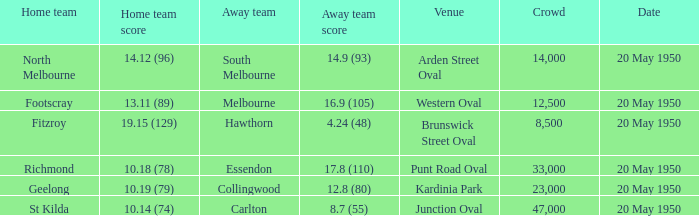I'm looking to parse the entire table for insights. Could you assist me with that? {'header': ['Home team', 'Home team score', 'Away team', 'Away team score', 'Venue', 'Crowd', 'Date'], 'rows': [['North Melbourne', '14.12 (96)', 'South Melbourne', '14.9 (93)', 'Arden Street Oval', '14,000', '20 May 1950'], ['Footscray', '13.11 (89)', 'Melbourne', '16.9 (105)', 'Western Oval', '12,500', '20 May 1950'], ['Fitzroy', '19.15 (129)', 'Hawthorn', '4.24 (48)', 'Brunswick Street Oval', '8,500', '20 May 1950'], ['Richmond', '10.18 (78)', 'Essendon', '17.8 (110)', 'Punt Road Oval', '33,000', '20 May 1950'], ['Geelong', '10.19 (79)', 'Collingwood', '12.8 (80)', 'Kardinia Park', '23,000', '20 May 1950'], ['St Kilda', '10.14 (74)', 'Carlton', '8.7 (55)', 'Junction Oval', '47,000', '20 May 1950']]} When fitzroy played as the home team, what was the score of the visiting team? 4.24 (48). 